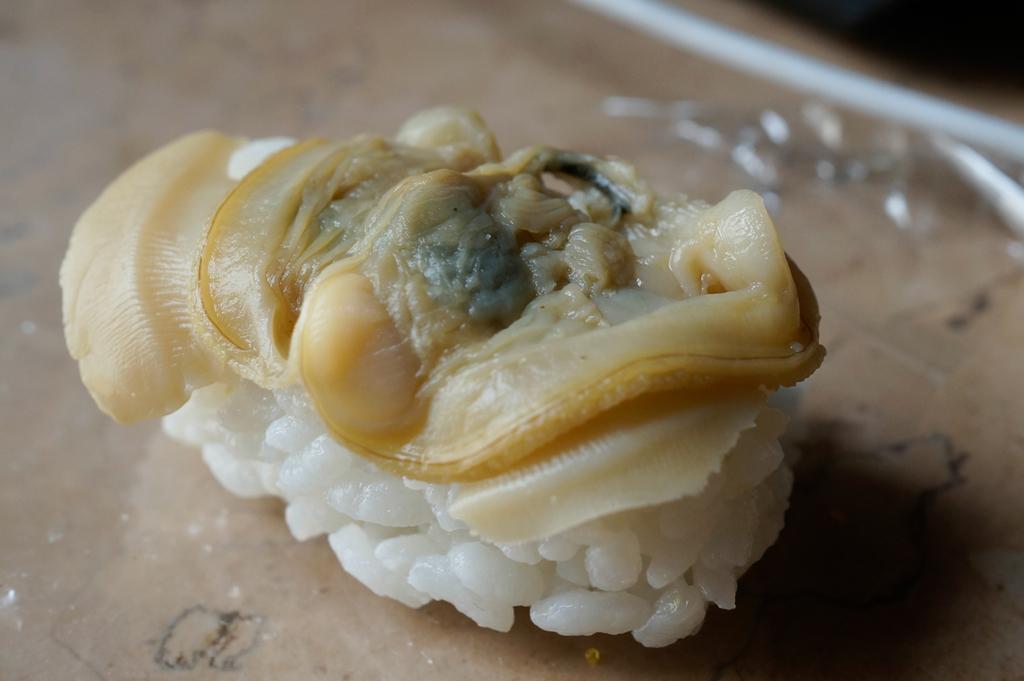Please provide a concise description of this image. In this image I can see a food stuff kept on the table. 